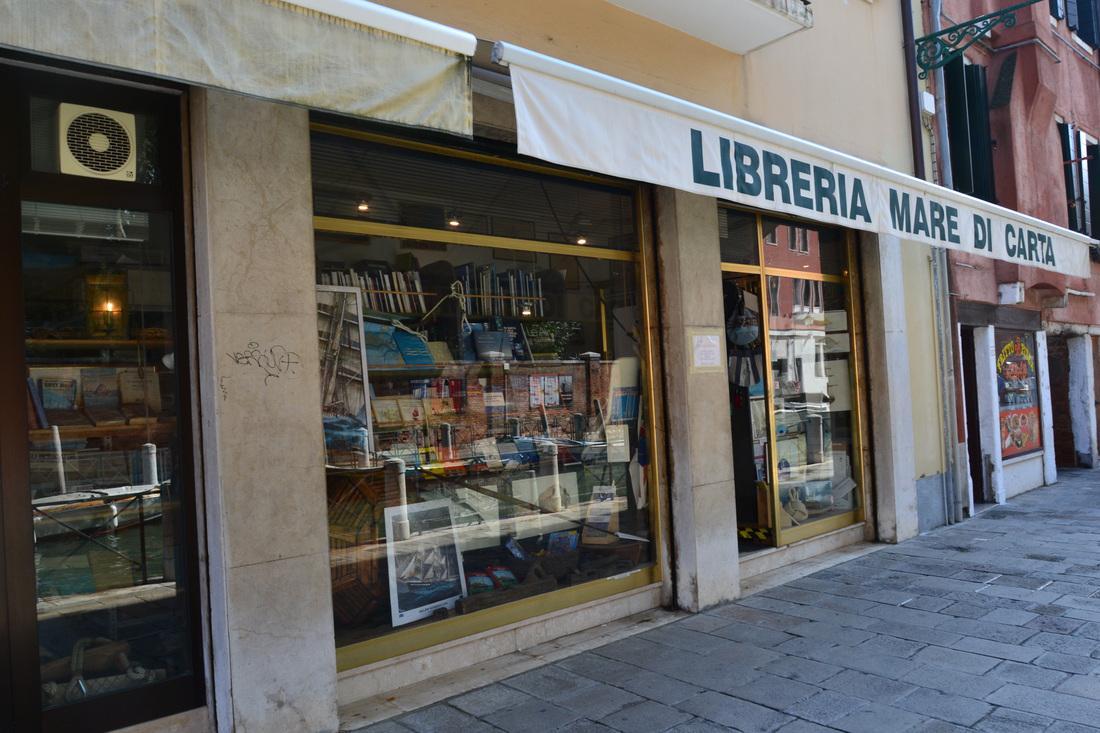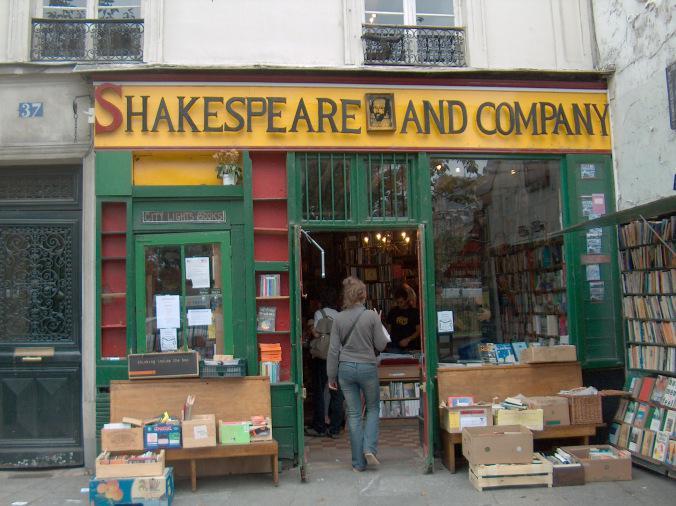The first image is the image on the left, the second image is the image on the right. For the images displayed, is the sentence "There are at least two green paint frames at the entrance of a bookstore." factually correct? Answer yes or no. Yes. The first image is the image on the left, the second image is the image on the right. Analyze the images presented: Is the assertion "The book shops pictured in the images on the left and right have the same color paint on their exterior, and at least one shop has windows divided into small panes." valid? Answer yes or no. No. 